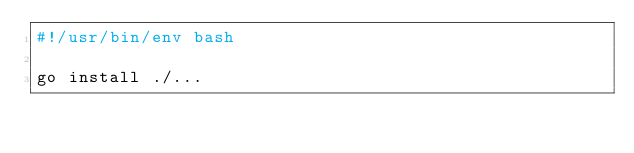Convert code to text. <code><loc_0><loc_0><loc_500><loc_500><_Bash_>#!/usr/bin/env bash

go install ./...
</code> 